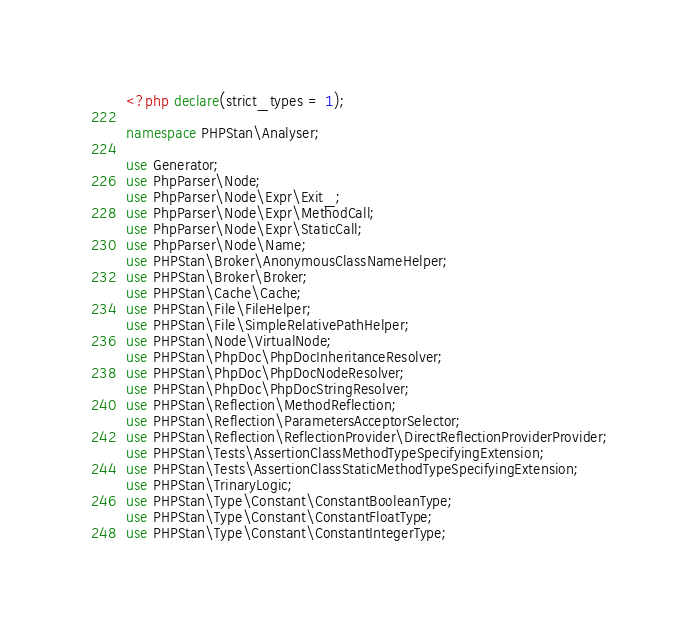Convert code to text. <code><loc_0><loc_0><loc_500><loc_500><_PHP_><?php declare(strict_types = 1);

namespace PHPStan\Analyser;

use Generator;
use PhpParser\Node;
use PhpParser\Node\Expr\Exit_;
use PhpParser\Node\Expr\MethodCall;
use PhpParser\Node\Expr\StaticCall;
use PhpParser\Node\Name;
use PHPStan\Broker\AnonymousClassNameHelper;
use PHPStan\Broker\Broker;
use PHPStan\Cache\Cache;
use PHPStan\File\FileHelper;
use PHPStan\File\SimpleRelativePathHelper;
use PHPStan\Node\VirtualNode;
use PHPStan\PhpDoc\PhpDocInheritanceResolver;
use PHPStan\PhpDoc\PhpDocNodeResolver;
use PHPStan\PhpDoc\PhpDocStringResolver;
use PHPStan\Reflection\MethodReflection;
use PHPStan\Reflection\ParametersAcceptorSelector;
use PHPStan\Reflection\ReflectionProvider\DirectReflectionProviderProvider;
use PHPStan\Tests\AssertionClassMethodTypeSpecifyingExtension;
use PHPStan\Tests\AssertionClassStaticMethodTypeSpecifyingExtension;
use PHPStan\TrinaryLogic;
use PHPStan\Type\Constant\ConstantBooleanType;
use PHPStan\Type\Constant\ConstantFloatType;
use PHPStan\Type\Constant\ConstantIntegerType;</code> 